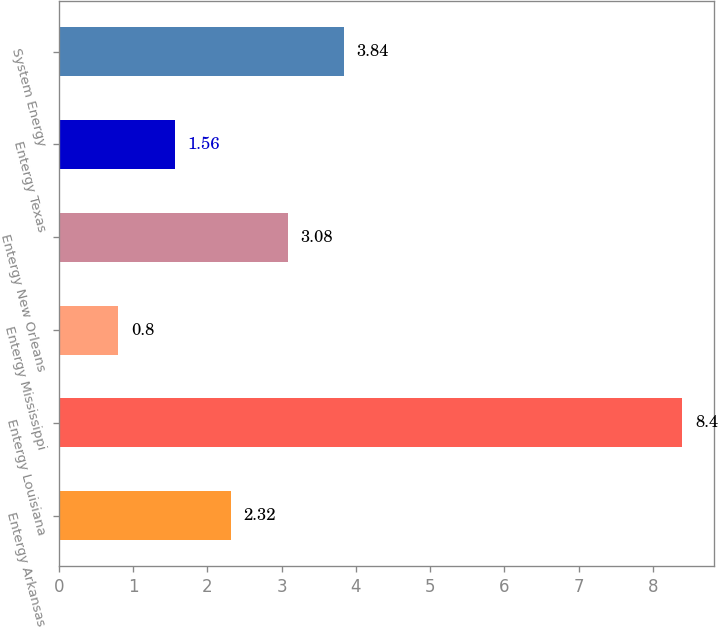Convert chart. <chart><loc_0><loc_0><loc_500><loc_500><bar_chart><fcel>Entergy Arkansas<fcel>Entergy Louisiana<fcel>Entergy Mississippi<fcel>Entergy New Orleans<fcel>Entergy Texas<fcel>System Energy<nl><fcel>2.32<fcel>8.4<fcel>0.8<fcel>3.08<fcel>1.56<fcel>3.84<nl></chart> 